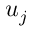Convert formula to latex. <formula><loc_0><loc_0><loc_500><loc_500>u _ { j }</formula> 